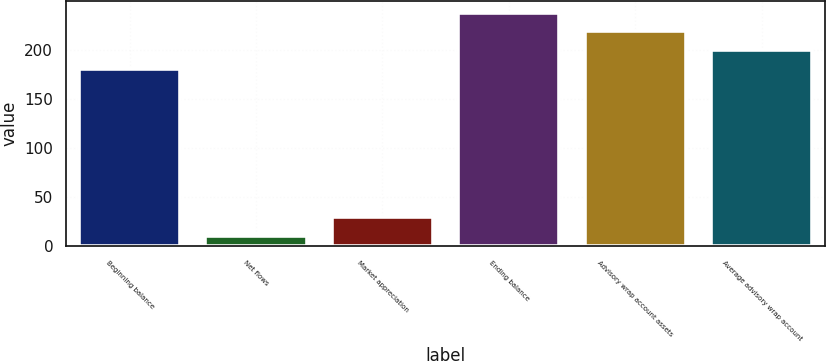Convert chart to OTSL. <chart><loc_0><loc_0><loc_500><loc_500><bar_chart><fcel>Beginning balance<fcel>Net flows<fcel>Market appreciation<fcel>Ending balance<fcel>Advisory wrap account assets<fcel>Average advisory wrap account<nl><fcel>180.5<fcel>10.2<fcel>29.29<fcel>237.77<fcel>218.68<fcel>199.59<nl></chart> 